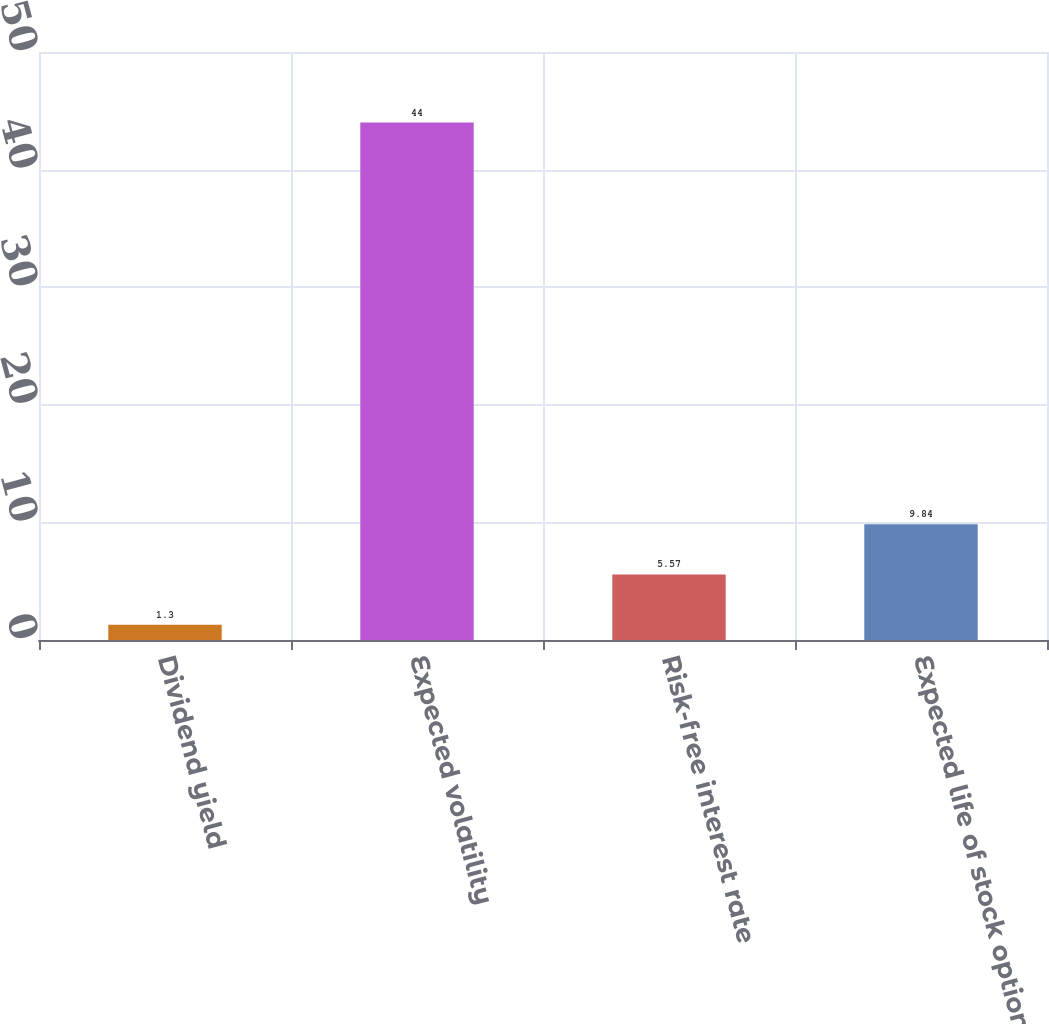<chart> <loc_0><loc_0><loc_500><loc_500><bar_chart><fcel>Dividend yield<fcel>Expected volatility<fcel>Risk-free interest rate<fcel>Expected life of stock option<nl><fcel>1.3<fcel>44<fcel>5.57<fcel>9.84<nl></chart> 